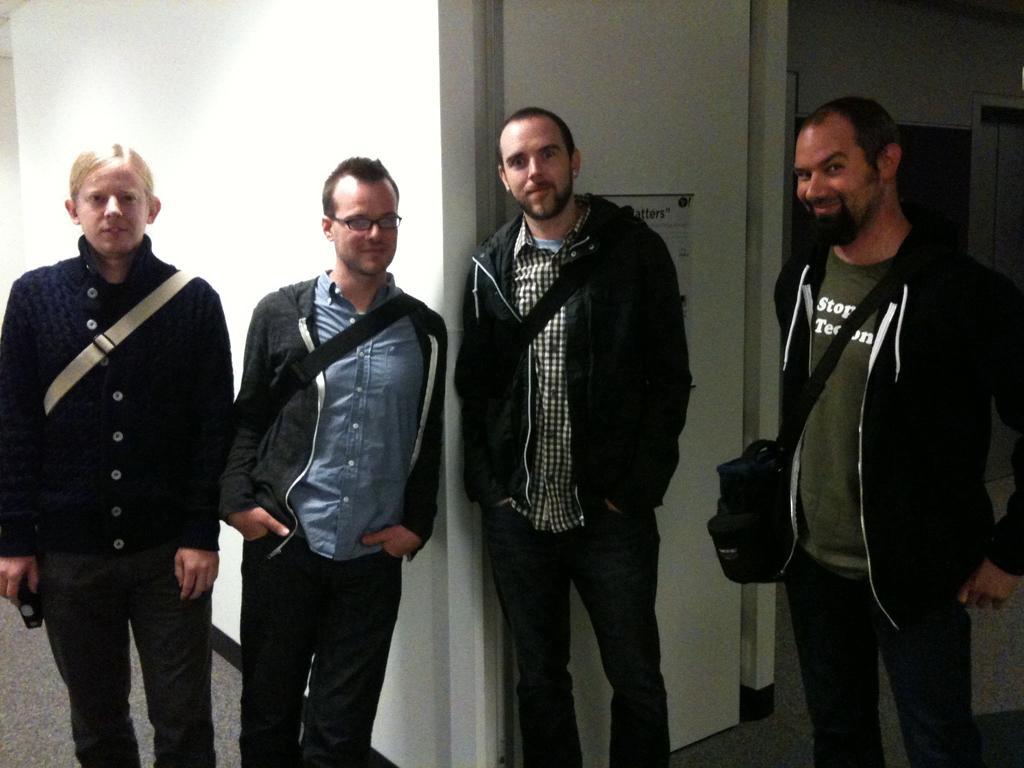Could you give a brief overview of what you see in this image? On the right side of the picture we can see a man wearing a bag with a good pretty smile on his face with lifting his eyebrow. Beside this man there is other man wearing a bag and jacket and also we can see the other person wearing a spects. On the left side of the picture there is a person standing. This a wall. This is a floor. 